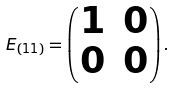<formula> <loc_0><loc_0><loc_500><loc_500>E _ { ( 1 1 ) } = \begin{pmatrix} 1 & 0 \\ 0 & 0 \end{pmatrix} .</formula> 